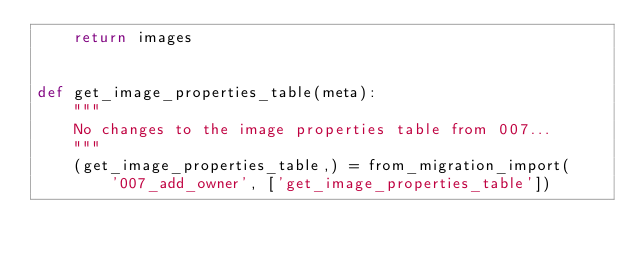<code> <loc_0><loc_0><loc_500><loc_500><_Python_>    return images


def get_image_properties_table(meta):
    """
    No changes to the image properties table from 007...
    """
    (get_image_properties_table,) = from_migration_import(
        '007_add_owner', ['get_image_properties_table'])
</code> 